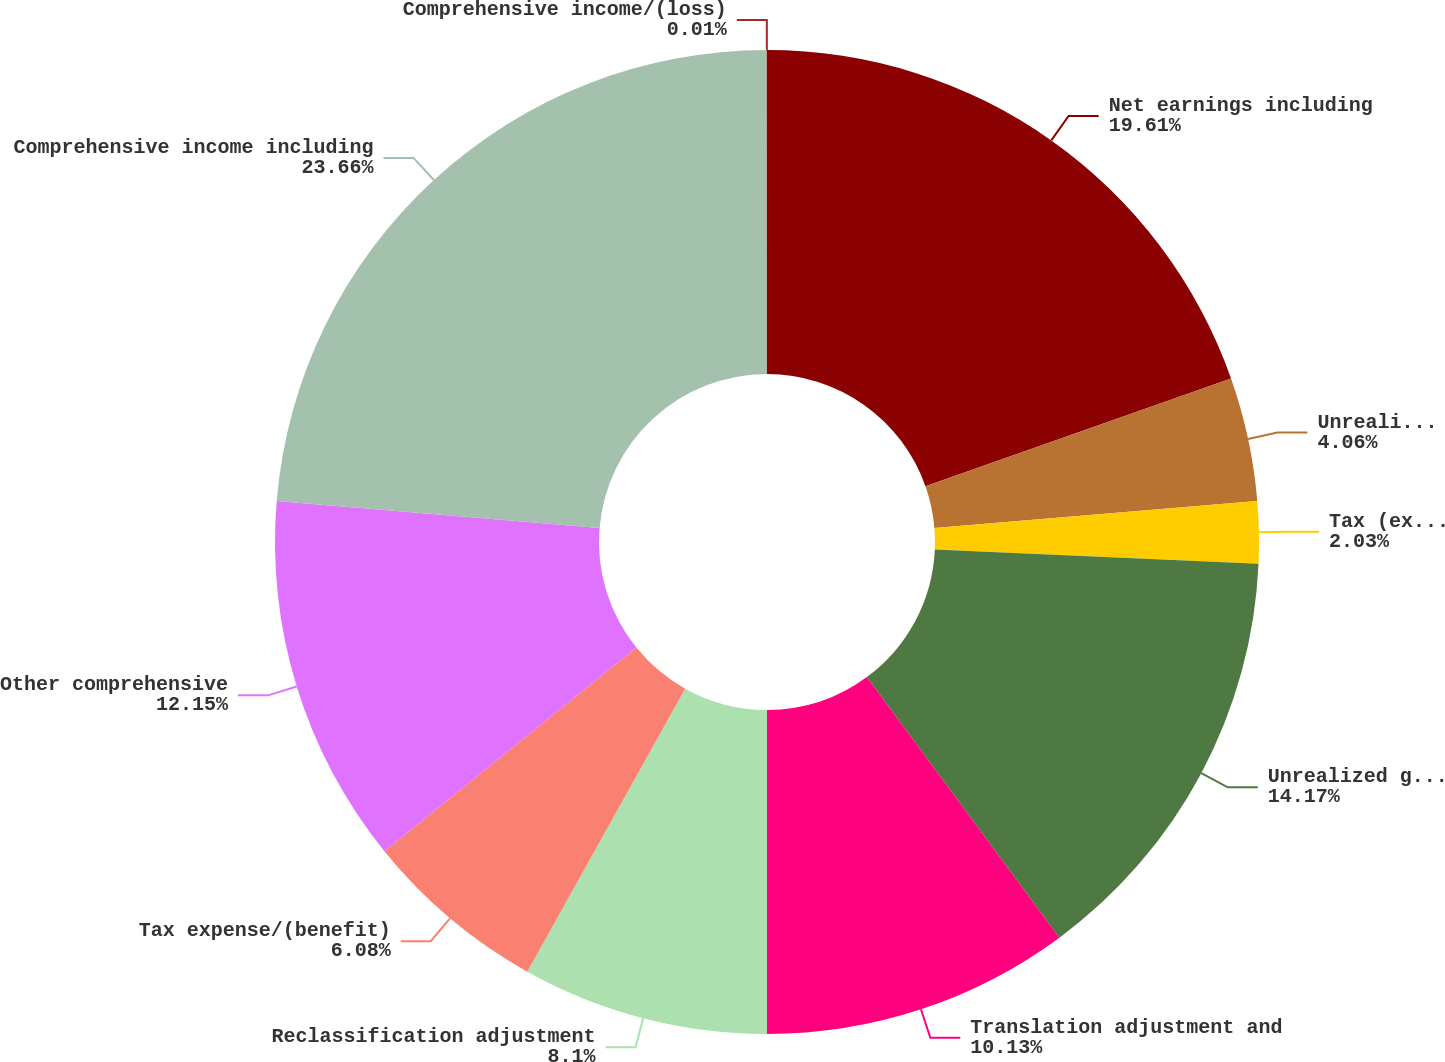Convert chart to OTSL. <chart><loc_0><loc_0><loc_500><loc_500><pie_chart><fcel>Net earnings including<fcel>Unrealized holding<fcel>Tax (expense)/benefit<fcel>Unrealized gains/(losses) on<fcel>Translation adjustment and<fcel>Reclassification adjustment<fcel>Tax expense/(benefit)<fcel>Other comprehensive<fcel>Comprehensive income including<fcel>Comprehensive income/(loss)<nl><fcel>19.61%<fcel>4.06%<fcel>2.03%<fcel>14.17%<fcel>10.13%<fcel>8.1%<fcel>6.08%<fcel>12.15%<fcel>23.66%<fcel>0.01%<nl></chart> 